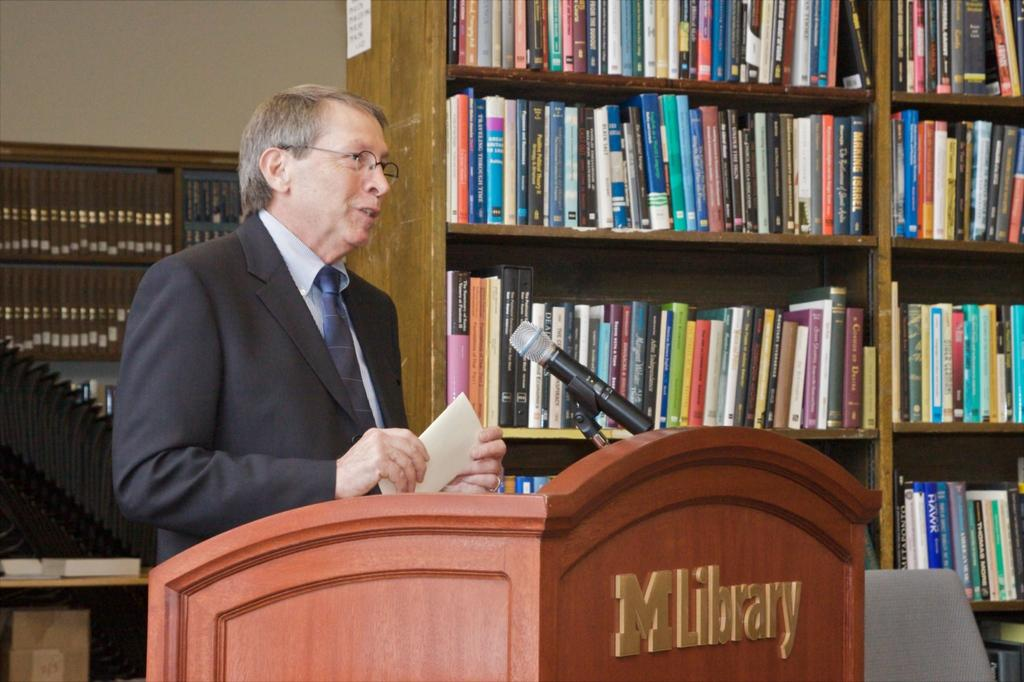<image>
Summarize the visual content of the image. Gentleman give a speech at the M libary with shelf full of books behind him. 